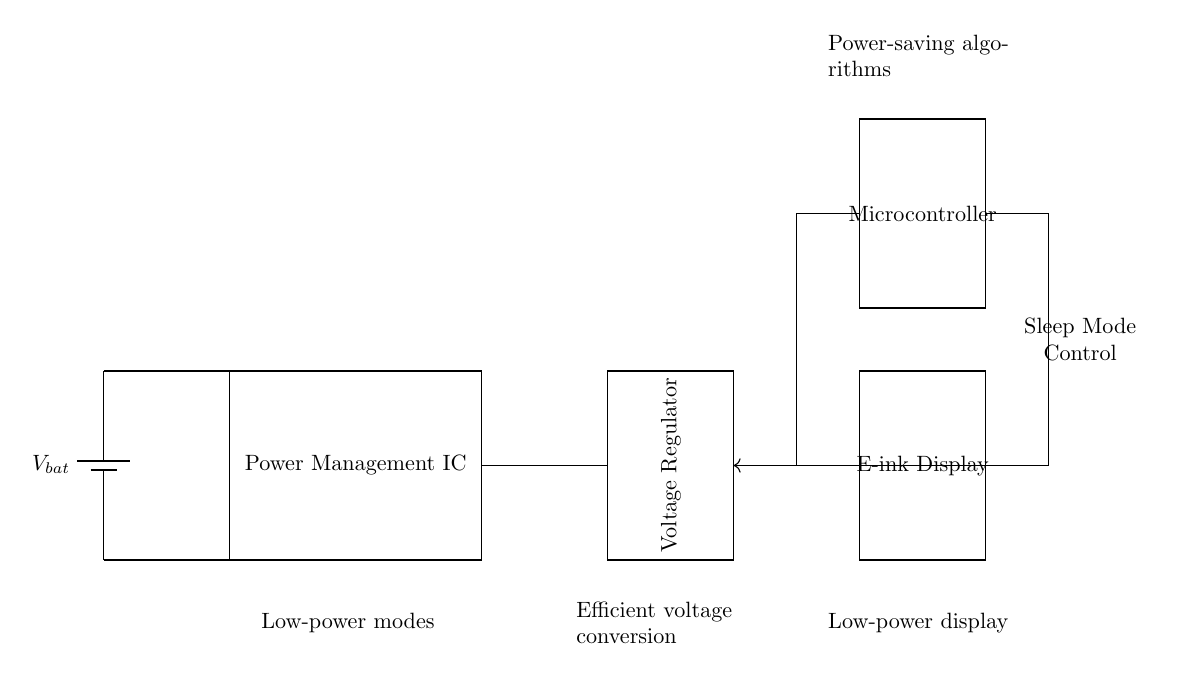What is the primary function of the Power Management IC? The Power Management IC regulates the power supply to ensure that the components receive the correct voltage and current levels needed for operation.
Answer: Regulates power supply What does the E-ink Display require for operation? The E-ink Display requires a stable voltage and a low-power supply, as indicated by its connection to the Voltage Regulator in the circuit diagram.
Answer: Stable voltage How does the Sleep Mode Control influence the circuit? The Sleep Mode Control reduces power consumption by putting the Microcontroller into a low-power state when the device is not in use, thereby extending battery life.
Answer: Reduces power consumption What type of conversion is represented by the Voltage Regulator? The Voltage Regulator performs efficient voltage conversion to adapt the battery voltage to the levels needed by the load and other components in the circuit.
Answer: Efficient voltage conversion Which component connects directly to the battery? The Power Management IC connects directly to the battery, receiving the voltage for regulation before it is delivered to other components.
Answer: Power Management IC How is power-saving achieved in this circuit? Power-saving is achieved through low-power modes utilized by the Microcontroller and the efficient operation of the E-ink Display, which is designed for minimal energy use.
Answer: Power-saving algorithms 